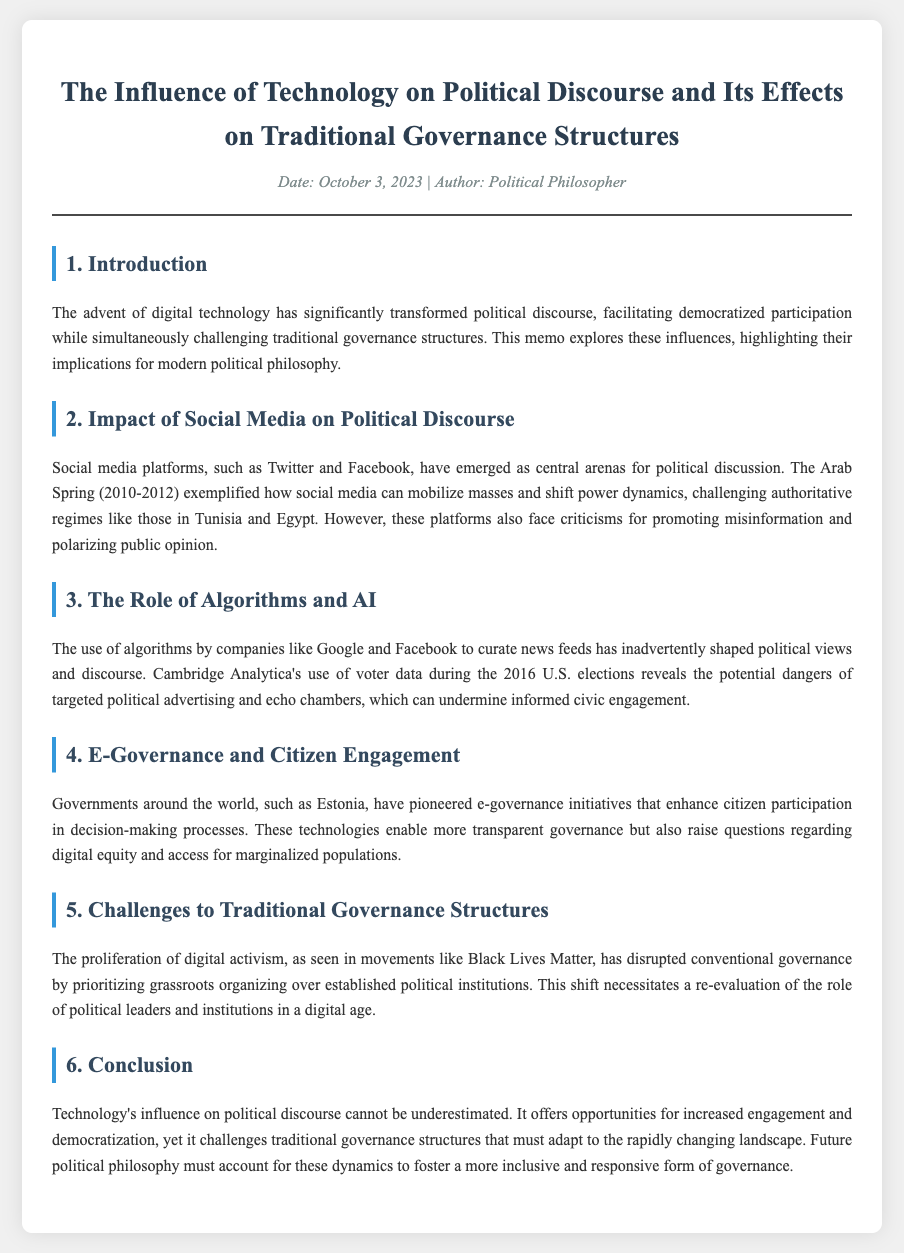What is the date of the memo? The date of the memo is mentioned in the meta section as October 3, 2023.
Answer: October 3, 2023 Who is the author of the memo? The author is indicated in the meta section of the memo as Political Philosopher.
Answer: Political Philosopher What social media platforms are highlighted in the document? The document specifies Twitter and Facebook as central arenas for political discussion.
Answer: Twitter and Facebook What significant event is used as an example of social media's influence? The document mentions the Arab Spring as an example of how social media can mobilize masses.
Answer: Arab Spring Which country's e-governance initiatives are mentioned? Estonia is referenced as a pioneer in e-governance initiatives enhancing citizen participation.
Answer: Estonia What movement is cited as disrupting conventional governance? The document refers to the Black Lives Matter movement as a disruptive force in governance.
Answer: Black Lives Matter What challenge does technology pose to traditional governance structures? The memo highlights that technology challenges traditional governance by promoting grassroots organizing over established institutions.
Answer: Grassroots organizing What is the main conclusion drawn in the document? The conclusion emphasizes that technology's influence on political discourse offers opportunities but challenges traditional governance.
Answer: Opportunities and challenges 